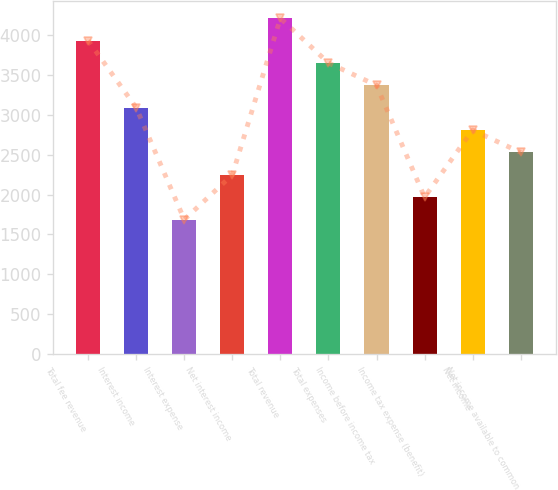Convert chart to OTSL. <chart><loc_0><loc_0><loc_500><loc_500><bar_chart><fcel>Total fee revenue<fcel>Interest income<fcel>Interest expense<fcel>Net interest income<fcel>Total revenue<fcel>Total expenses<fcel>Income before income tax<fcel>Income tax expense (benefit)<fcel>Net income<fcel>Net income available to common<nl><fcel>3933.82<fcel>3090.94<fcel>1686.14<fcel>2248.06<fcel>4214.78<fcel>3652.86<fcel>3371.9<fcel>1967.1<fcel>2809.98<fcel>2529.02<nl></chart> 